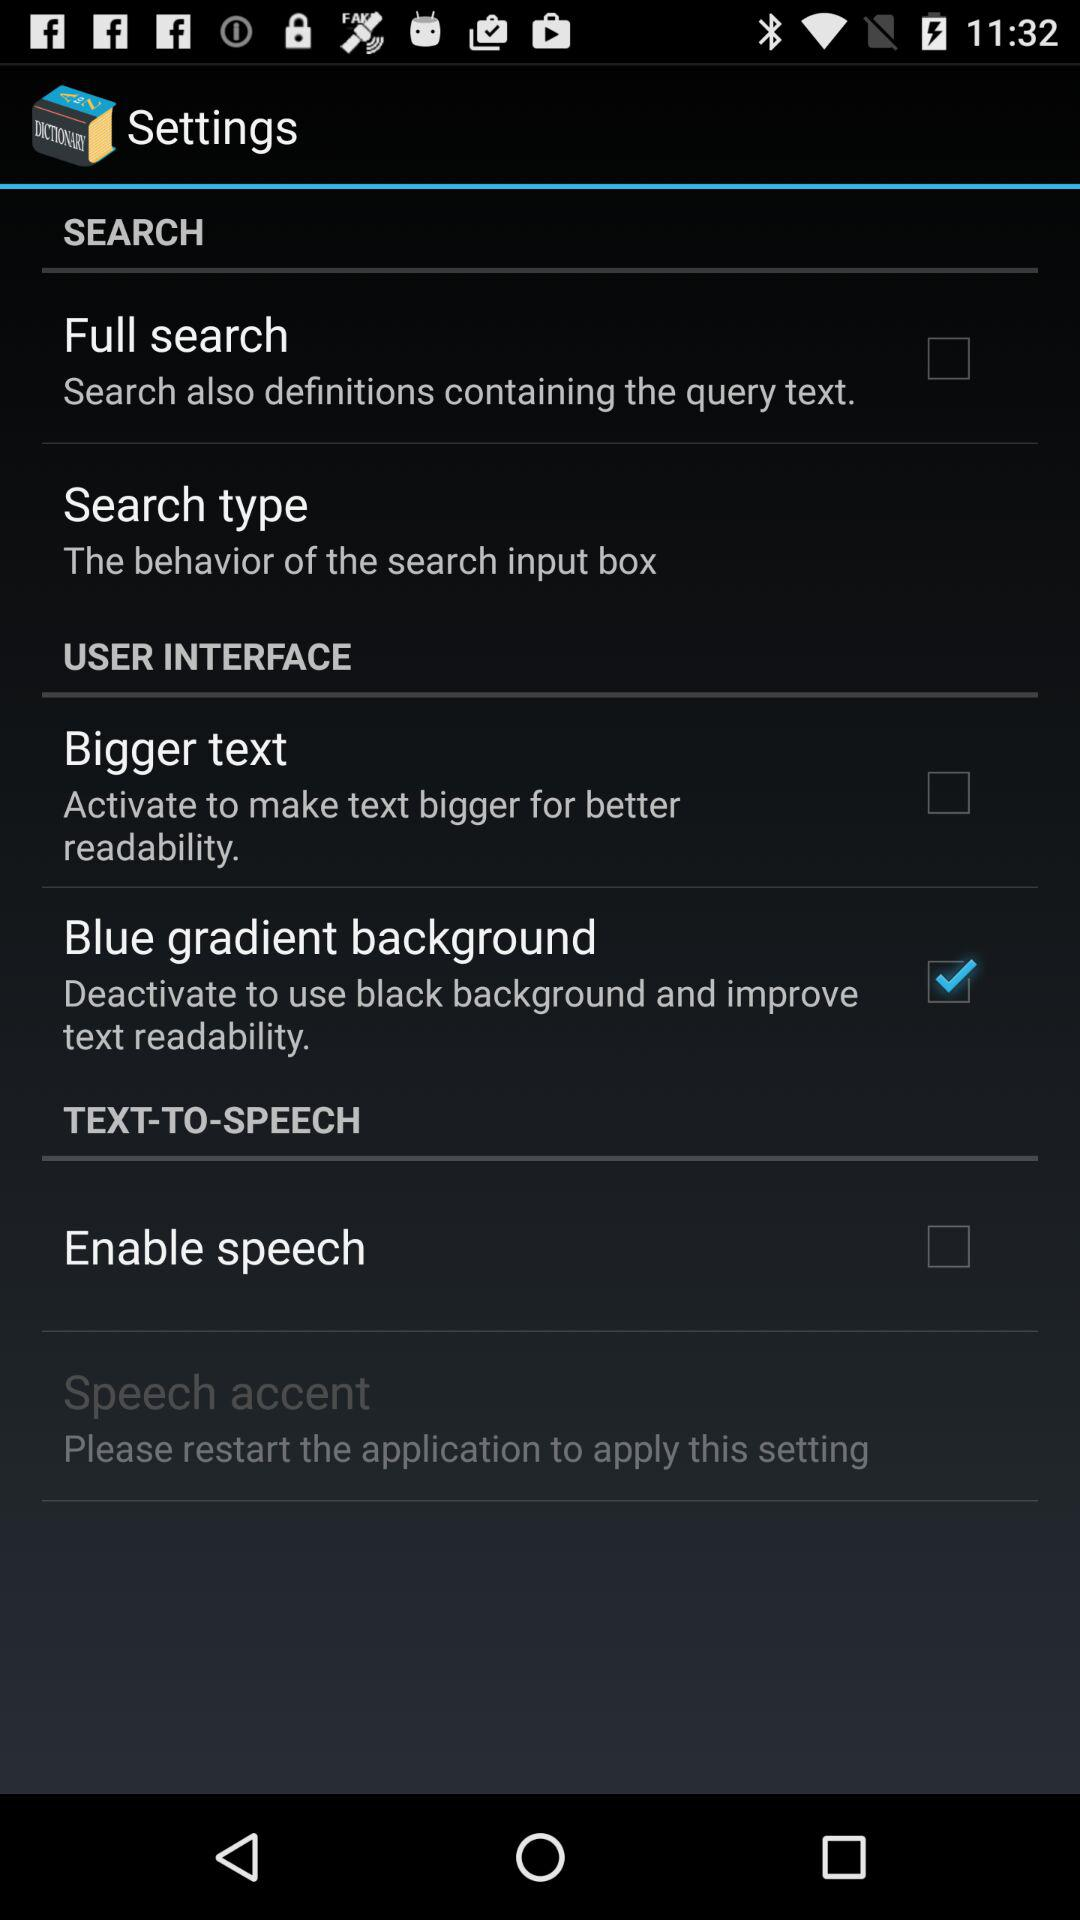What is the current status of the "Full search"? The status is "off". 